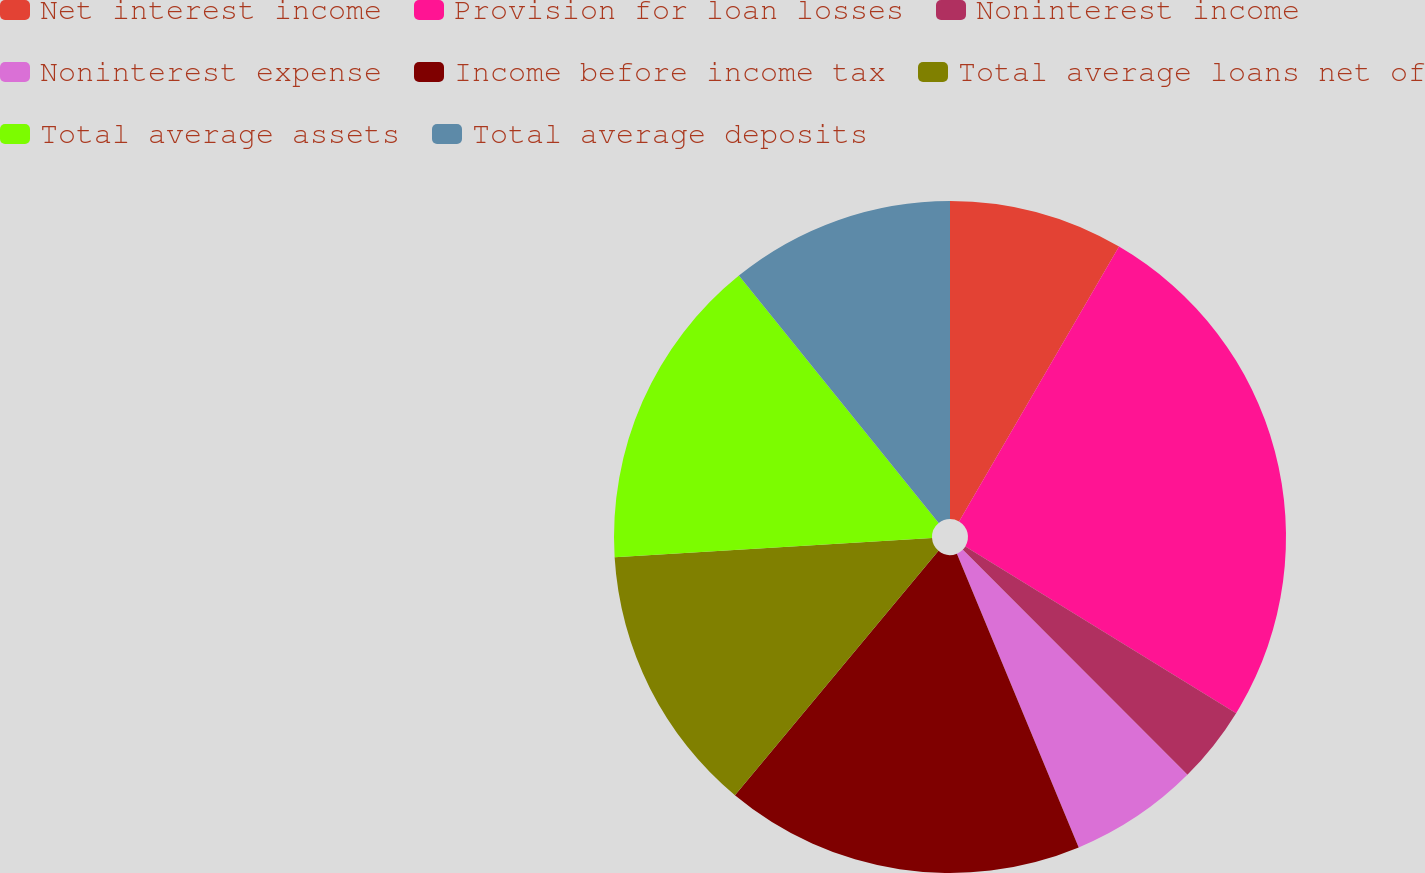Convert chart. <chart><loc_0><loc_0><loc_500><loc_500><pie_chart><fcel>Net interest income<fcel>Provision for loan losses<fcel>Noninterest income<fcel>Noninterest expense<fcel>Income before income tax<fcel>Total average loans net of<fcel>Total average assets<fcel>Total average deposits<nl><fcel>8.39%<fcel>25.39%<fcel>3.73%<fcel>6.23%<fcel>17.31%<fcel>12.98%<fcel>15.15%<fcel>10.81%<nl></chart> 